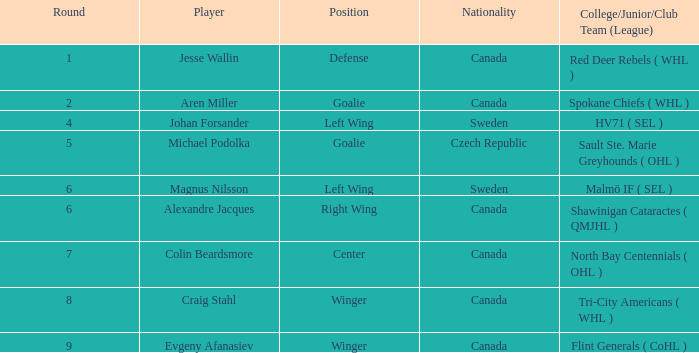In canada, which class of school, junior, or club group has a goalie position? Spokane Chiefs ( WHL ). 